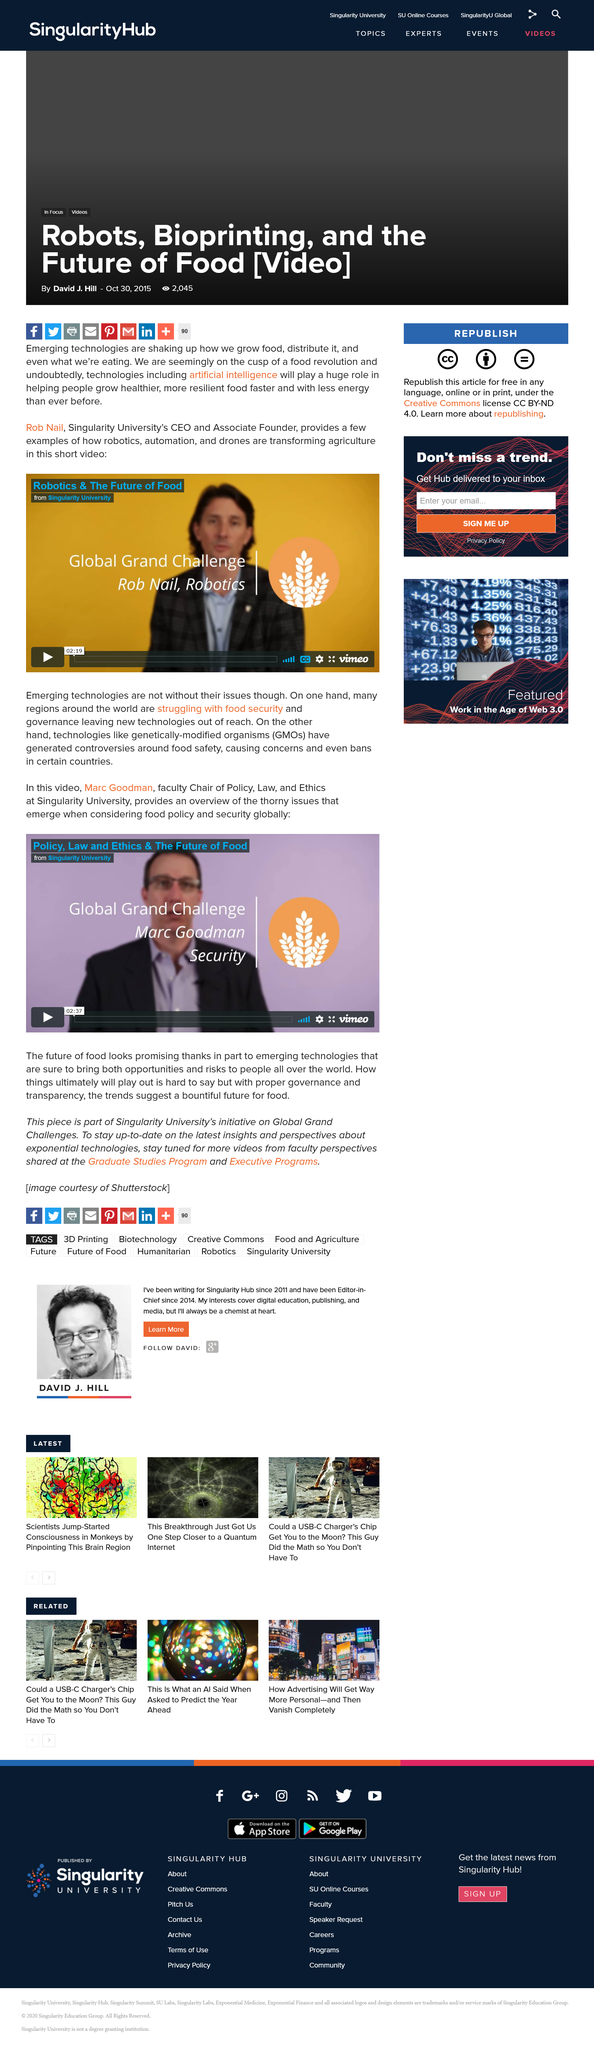List a handful of essential elements in this visual. Drones are an emerging technology that have been gaining increasing attention and adoption in recent years. For a bountiful future for food, it is imperative to prioritize proper governance and transparency in all aspects of the food system. Marc Goodman is the faculty Chair of Policy, Law, and Ethics. Marc Goodman provides an overview of the complex and difficult challenges that arise when addressing food policy and security on a global scale. It is not the case that Rob Nail has very short hair. 